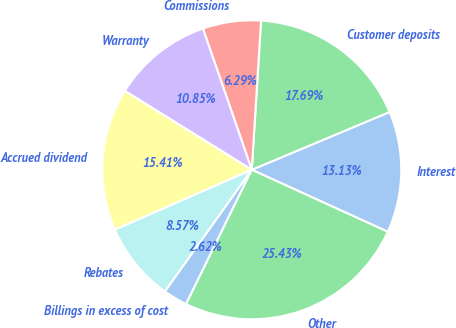Convert chart. <chart><loc_0><loc_0><loc_500><loc_500><pie_chart><fcel>Interest<fcel>Customer deposits<fcel>Commissions<fcel>Warranty<fcel>Accrued dividend<fcel>Rebates<fcel>Billings in excess of cost<fcel>Other<nl><fcel>13.13%<fcel>17.69%<fcel>6.29%<fcel>10.85%<fcel>15.41%<fcel>8.57%<fcel>2.62%<fcel>25.43%<nl></chart> 